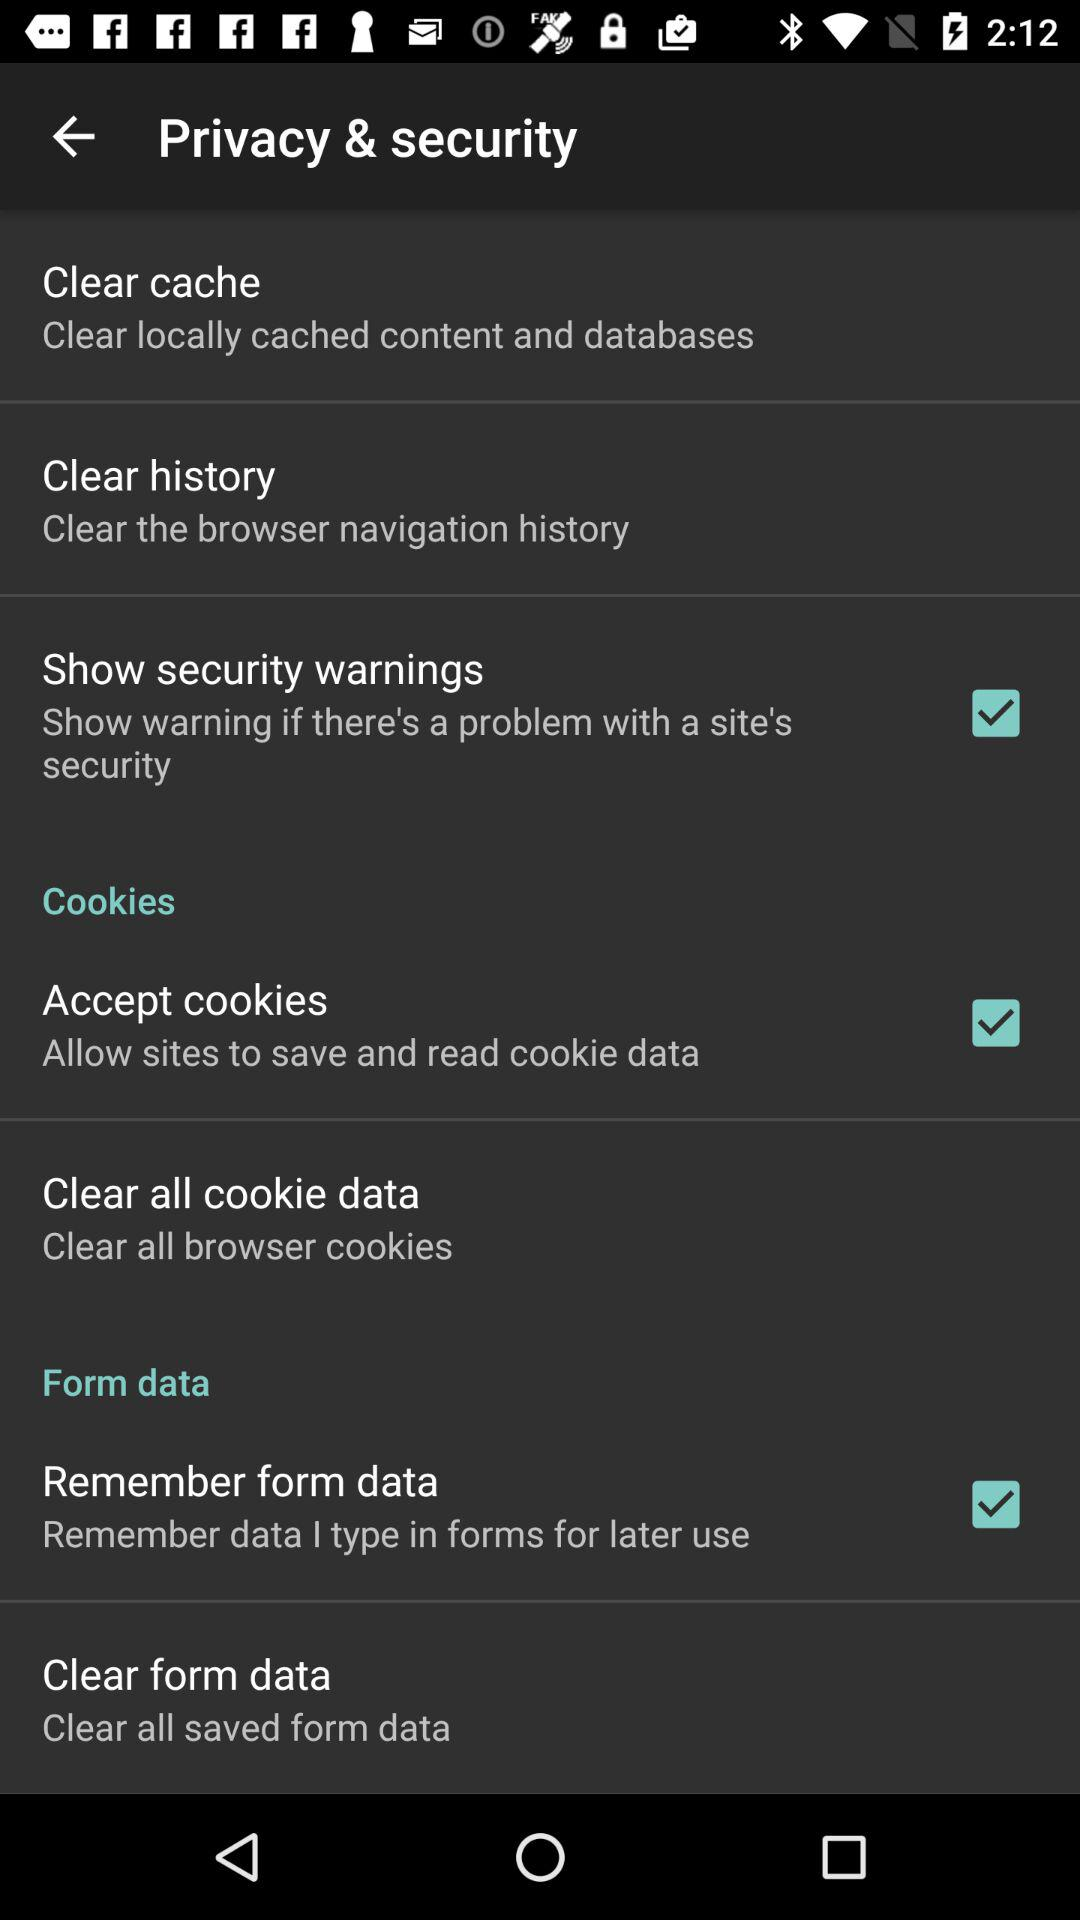What options are selected on the application? The options that are selected on the application are "Show security warnings", "Accept cookies" and "Remember form data". 